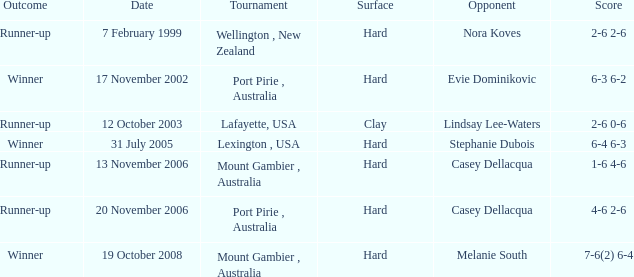Parse the full table. {'header': ['Outcome', 'Date', 'Tournament', 'Surface', 'Opponent', 'Score'], 'rows': [['Runner-up', '7 February 1999', 'Wellington , New Zealand', 'Hard', 'Nora Koves', '2-6 2-6'], ['Winner', '17 November 2002', 'Port Pirie , Australia', 'Hard', 'Evie Dominikovic', '6-3 6-2'], ['Runner-up', '12 October 2003', 'Lafayette, USA', 'Clay', 'Lindsay Lee-Waters', '2-6 0-6'], ['Winner', '31 July 2005', 'Lexington , USA', 'Hard', 'Stephanie Dubois', '6-4 6-3'], ['Runner-up', '13 November 2006', 'Mount Gambier , Australia', 'Hard', 'Casey Dellacqua', '1-6 4-6'], ['Runner-up', '20 November 2006', 'Port Pirie , Australia', 'Hard', 'Casey Dellacqua', '4-6 2-6'], ['Winner', '19 October 2008', 'Mount Gambier , Australia', 'Hard', 'Melanie South', '7-6(2) 6-4']]} On october 19, 2008, which tournament produced a winner? Mount Gambier , Australia. 